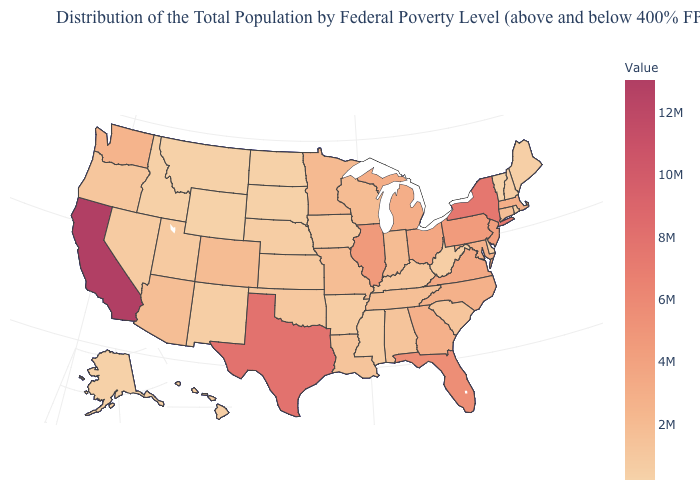Does the map have missing data?
Quick response, please. No. Does California have the highest value in the USA?
Concise answer only. Yes. Among the states that border Texas , which have the lowest value?
Answer briefly. New Mexico. Among the states that border Nevada , which have the lowest value?
Be succinct. Idaho. Which states have the highest value in the USA?
Keep it brief. California. Does the map have missing data?
Quick response, please. No. 